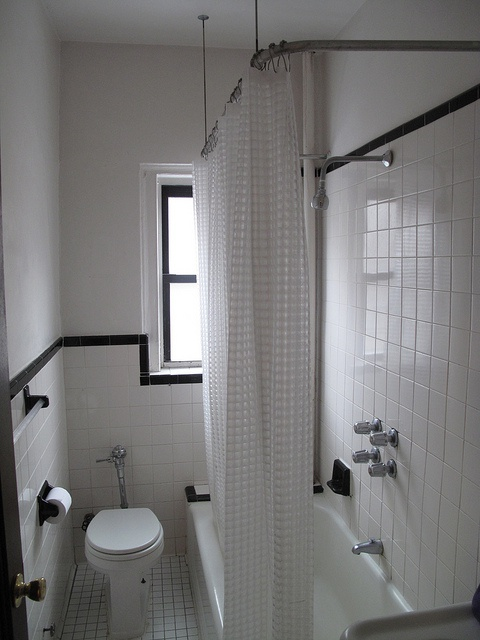Describe the objects in this image and their specific colors. I can see toilet in gray, darkgray, and black tones and sink in gray and black tones in this image. 